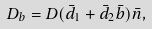Convert formula to latex. <formula><loc_0><loc_0><loc_500><loc_500>D _ { b } = D ( { \bar { d } } _ { 1 } + { \bar { d } } _ { 2 } { \bar { b } } ) { \bar { n } } ,</formula> 